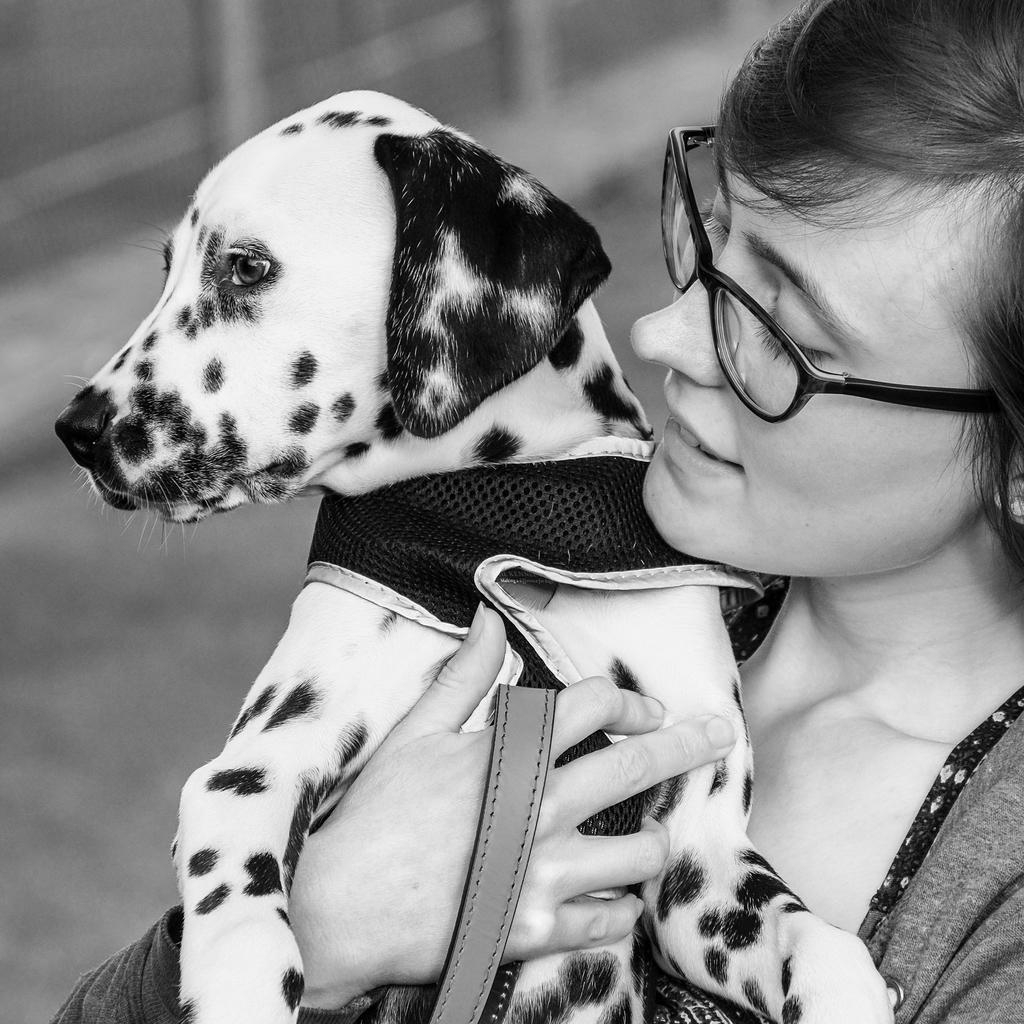In one or two sentences, can you explain what this image depicts? In this picture I can observe a woman holding a dog in her hand. She is wearing spectacles. This is a black and white image. 